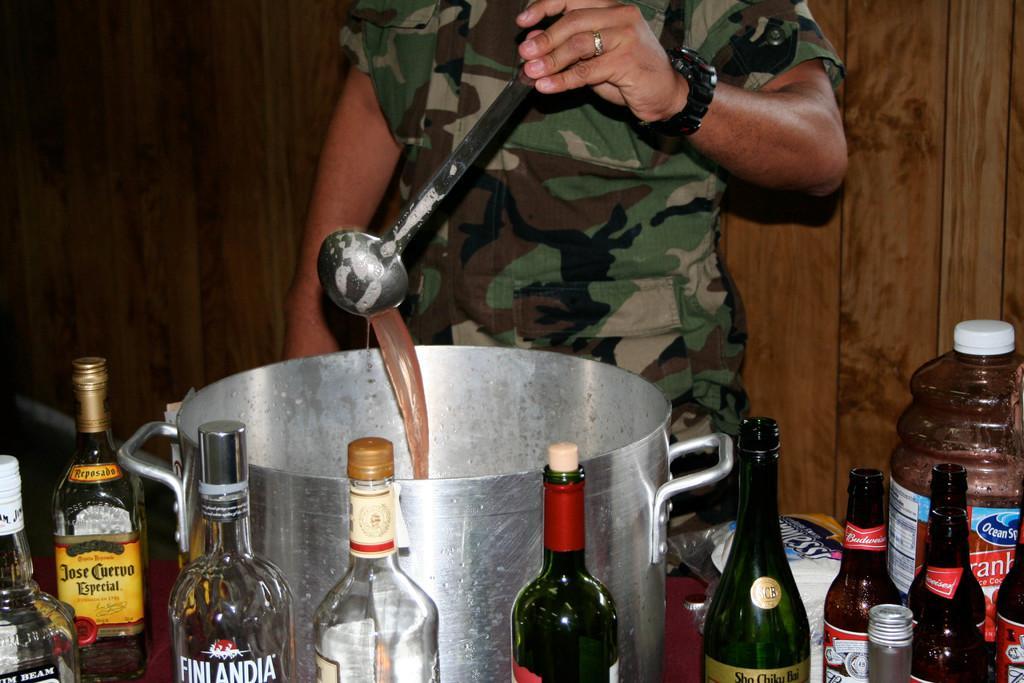Can you describe this image briefly? In this image i can see a man holding spoon and standing there are few bottles on a table at the back ground i can see a wooden wall. 